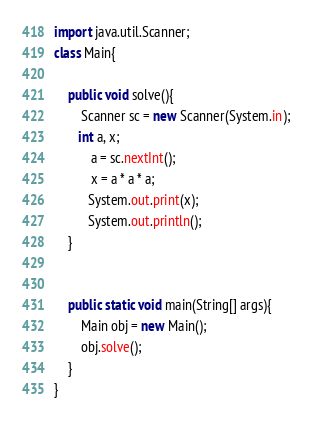<code> <loc_0><loc_0><loc_500><loc_500><_Java_>import java.util.Scanner;
class Main{
 
    public void solve(){
		Scanner sc = new Scanner(System.in);
       int a, x;
       	   a = sc.nextInt();
		   x = a * a * a;
		  System.out.print(x);
		  System.out.println();
    }
		   
	   
    public static void main(String[] args){
        Main obj = new Main();
        obj.solve();
    }
}</code> 